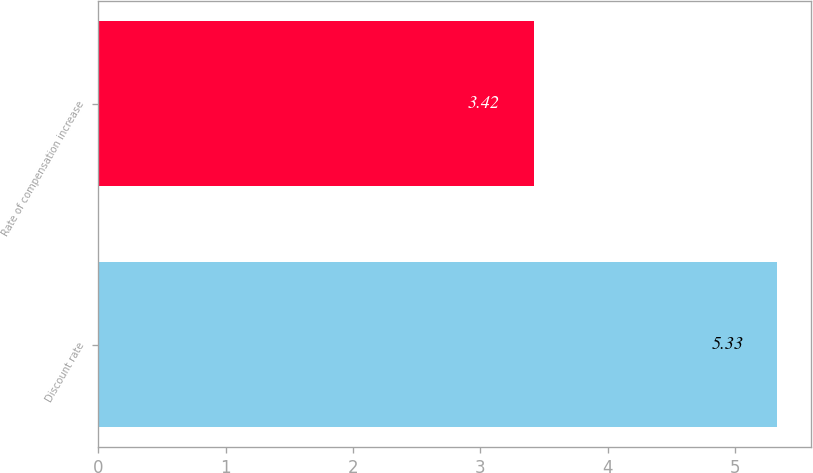Convert chart to OTSL. <chart><loc_0><loc_0><loc_500><loc_500><bar_chart><fcel>Discount rate<fcel>Rate of compensation increase<nl><fcel>5.33<fcel>3.42<nl></chart> 